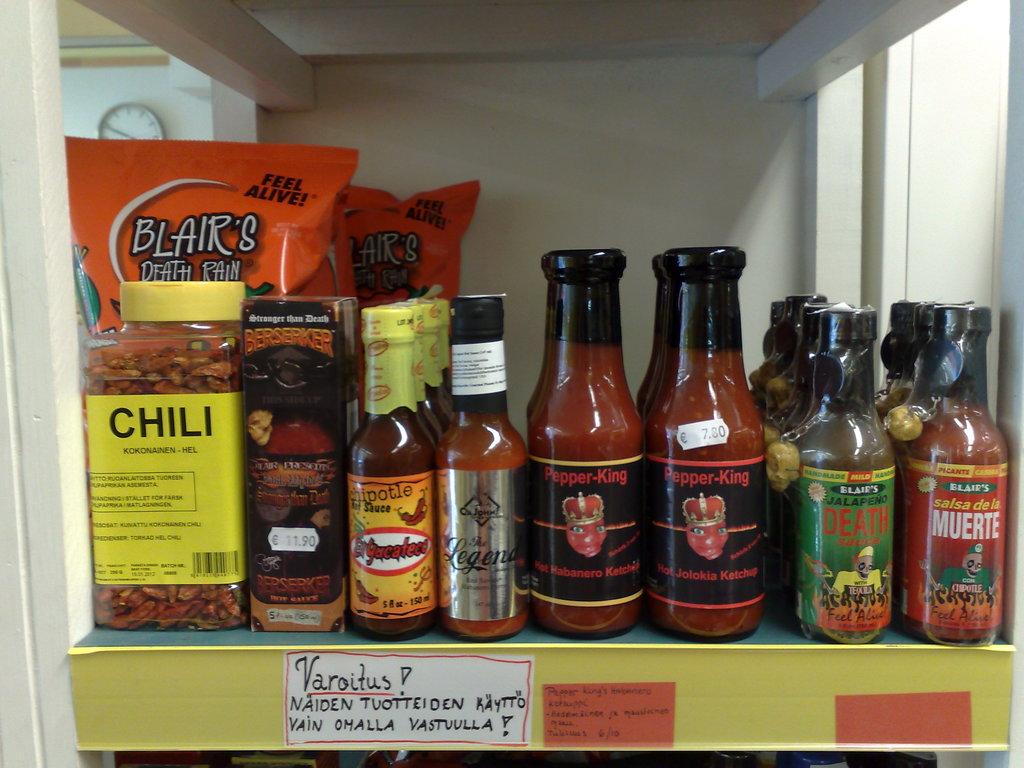What type of condiments are these?
Offer a very short reply. Hot sauces. What is on the yellow container on the far left?
Provide a short and direct response. Chili. 